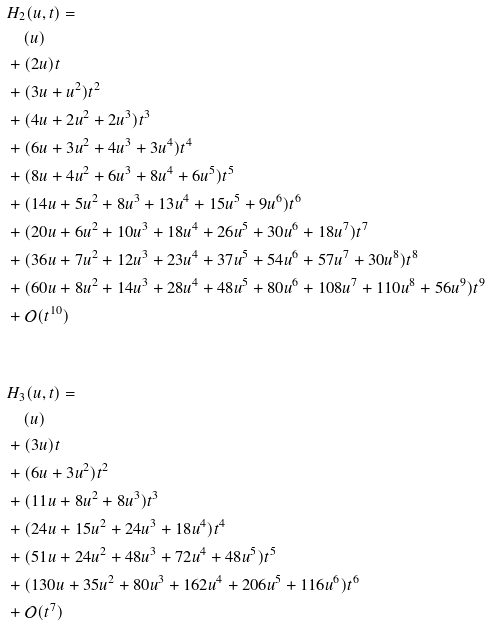<formula> <loc_0><loc_0><loc_500><loc_500>\ & H _ { 2 } ( u , t ) = \\ & \quad ( u ) \\ & + ( 2 u ) t \\ & + ( 3 u + u ^ { 2 } ) t ^ { 2 } \\ & + ( 4 u + 2 u ^ { 2 } + 2 u ^ { 3 } ) t ^ { 3 } \\ & + ( 6 u + 3 u ^ { 2 } + 4 u ^ { 3 } + 3 u ^ { 4 } ) t ^ { 4 } \\ & + ( 8 u + 4 u ^ { 2 } + 6 u ^ { 3 } + 8 u ^ { 4 } + 6 u ^ { 5 } ) t ^ { 5 } \\ & + ( 1 4 u + 5 u ^ { 2 } + 8 u ^ { 3 } + 1 3 u ^ { 4 } + 1 5 u ^ { 5 } + 9 u ^ { 6 } ) t ^ { 6 } \\ & + ( 2 0 u + 6 u ^ { 2 } + 1 0 u ^ { 3 } + 1 8 u ^ { 4 } + 2 6 u ^ { 5 } + 3 0 u ^ { 6 } + 1 8 u ^ { 7 } ) t ^ { 7 } \\ & + ( 3 6 u + 7 u ^ { 2 } + 1 2 u ^ { 3 } + 2 3 u ^ { 4 } + 3 7 u ^ { 5 } + 5 4 u ^ { 6 } + 5 7 u ^ { 7 } + 3 0 u ^ { 8 } ) t ^ { 8 } \\ & + ( 6 0 u + 8 u ^ { 2 } + 1 4 u ^ { 3 } + 2 8 u ^ { 4 } + 4 8 u ^ { 5 } + 8 0 u ^ { 6 } + 1 0 8 u ^ { 7 } + 1 1 0 u ^ { 8 } + 5 6 u ^ { 9 } ) t ^ { 9 } \\ & + \mathcal { O } ( t ^ { 1 0 } ) \\ & \\ & \\ & H _ { 3 } ( u , t ) = \\ & \quad ( u ) \\ & + ( 3 u ) t \\ & + ( 6 u + 3 u ^ { 2 } ) t ^ { 2 } \\ & + ( 1 1 u + 8 u ^ { 2 } + 8 u ^ { 3 } ) t ^ { 3 } \\ & + ( 2 4 u + 1 5 u ^ { 2 } + 2 4 u ^ { 3 } + 1 8 u ^ { 4 } ) t ^ { 4 } \\ & + ( 5 1 u + 2 4 u ^ { 2 } + 4 8 u ^ { 3 } + 7 2 u ^ { 4 } + 4 8 u ^ { 5 } ) t ^ { 5 } \\ & + ( 1 3 0 u + 3 5 u ^ { 2 } + 8 0 u ^ { 3 } + 1 6 2 u ^ { 4 } + 2 0 6 u ^ { 5 } + 1 1 6 u ^ { 6 } ) t ^ { 6 } \\ & + \mathcal { O } ( t ^ { 7 } )</formula> 